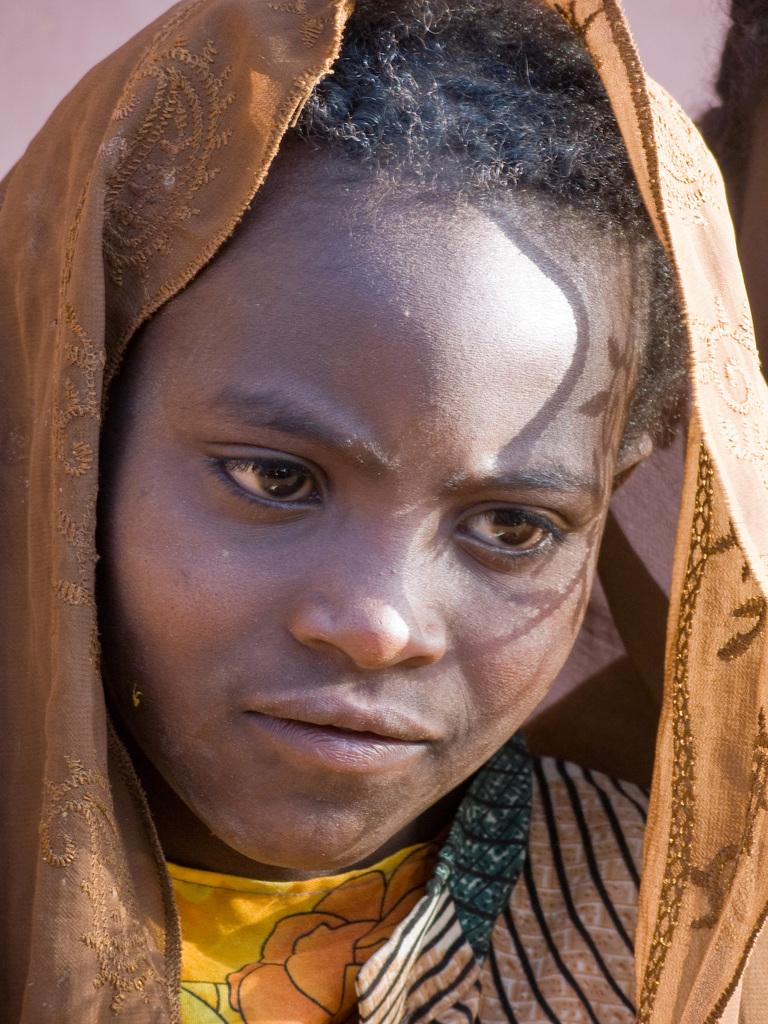Who or what is present in the image? There is a person in the image. What is the person wearing on their head? The person is wearing a scarf on their head. What language is the person speaking in the image? The image does not provide any information about the language being spoken, as there is no audio or text present. 